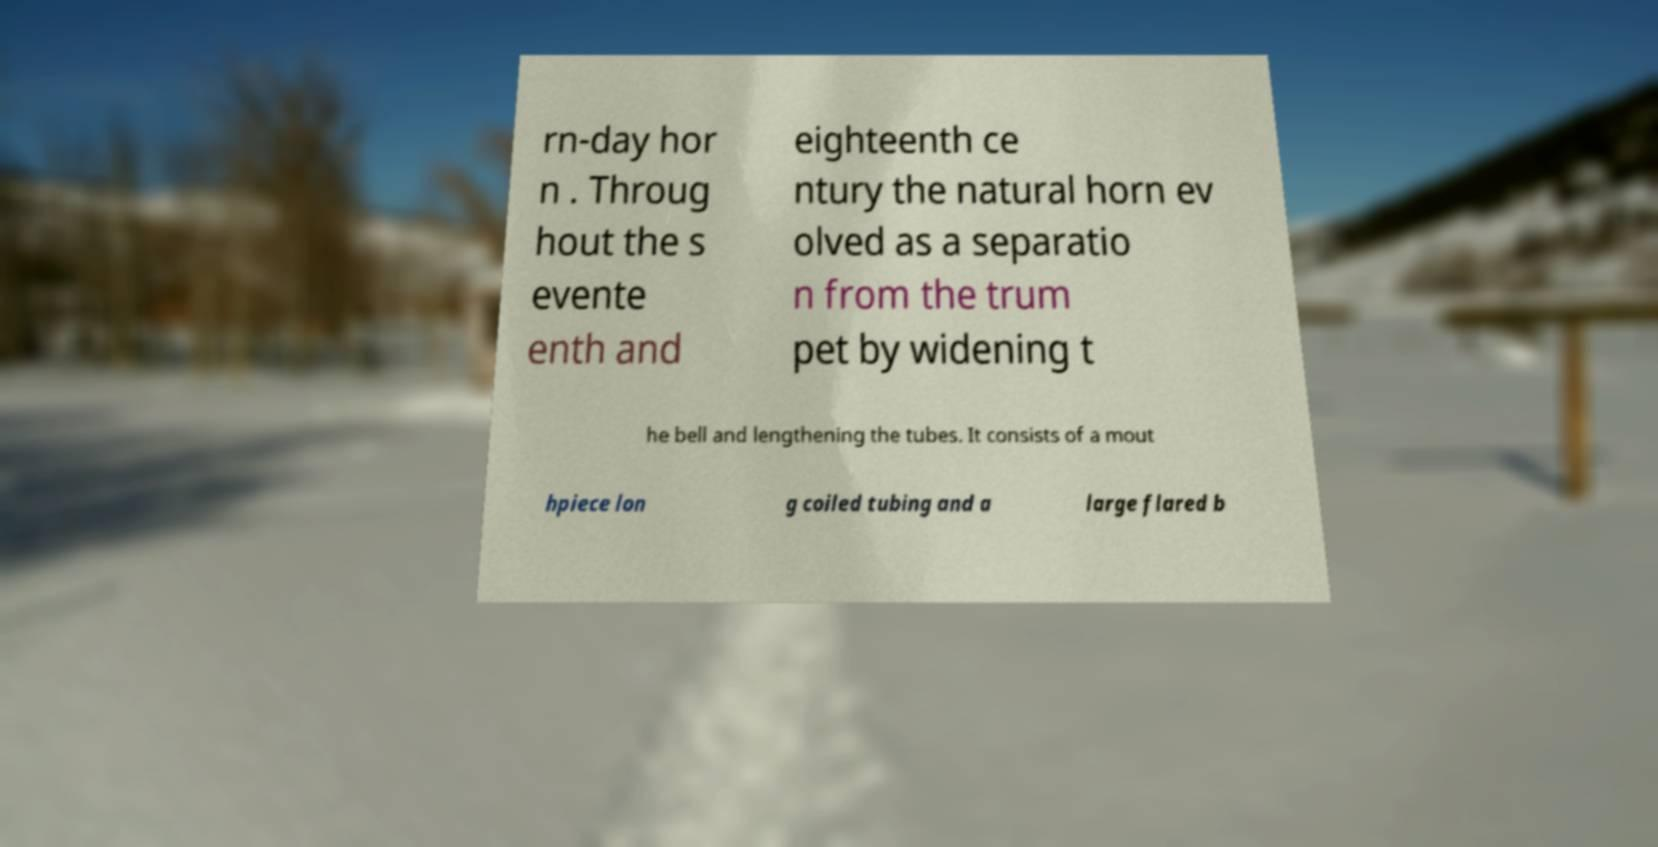For documentation purposes, I need the text within this image transcribed. Could you provide that? rn-day hor n . Throug hout the s evente enth and eighteenth ce ntury the natural horn ev olved as a separatio n from the trum pet by widening t he bell and lengthening the tubes. It consists of a mout hpiece lon g coiled tubing and a large flared b 